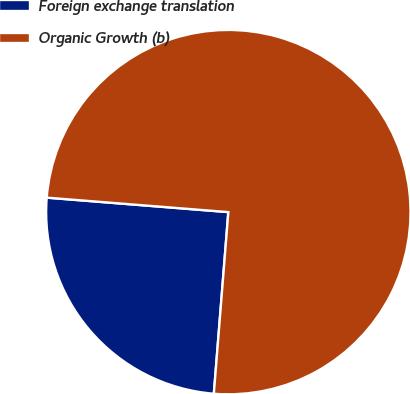<chart> <loc_0><loc_0><loc_500><loc_500><pie_chart><fcel>Foreign exchange translation<fcel>Organic Growth (b)<nl><fcel>25.0%<fcel>75.0%<nl></chart> 